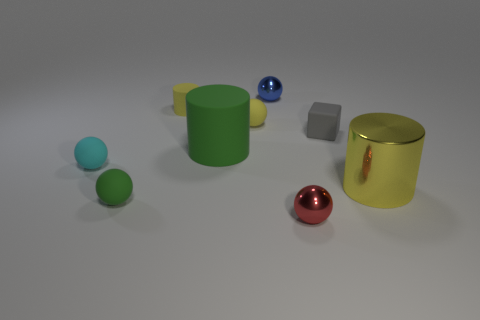Are there any other things that are the same shape as the small gray object?
Your response must be concise. No. The small blue thing is what shape?
Your response must be concise. Sphere. Is the shape of the metal object that is to the left of the small red ball the same as  the cyan object?
Offer a terse response. Yes. Is the number of small things behind the gray matte thing greater than the number of blue metal objects that are in front of the big metallic cylinder?
Ensure brevity in your answer.  Yes. What number of other things are there of the same size as the green matte cylinder?
Provide a succinct answer. 1. Does the cyan thing have the same shape as the green rubber thing in front of the yellow metallic cylinder?
Your answer should be very brief. Yes. How many metallic objects are large cylinders or small blue things?
Offer a terse response. 2. Is there a ball of the same color as the big rubber object?
Provide a succinct answer. Yes. Is there a gray shiny cube?
Keep it short and to the point. No. Is the small gray object the same shape as the tiny red thing?
Keep it short and to the point. No. 